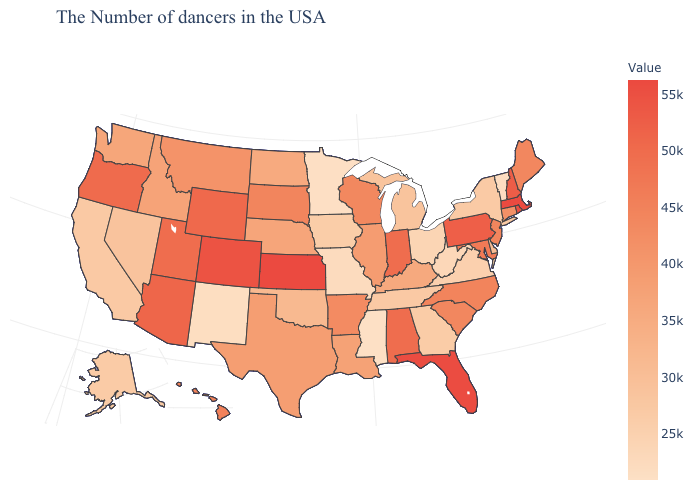Which states have the lowest value in the West?
Short answer required. New Mexico. Does Vermont have the lowest value in the Northeast?
Write a very short answer. Yes. Among the states that border Massachusetts , which have the lowest value?
Be succinct. Vermont. 